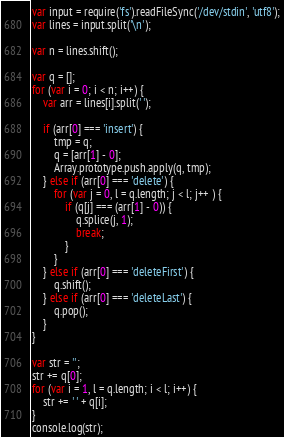Convert code to text. <code><loc_0><loc_0><loc_500><loc_500><_JavaScript_>var input = require('fs').readFileSync('/dev/stdin', 'utf8');
var lines = input.split('\n');

var n = lines.shift();

var q = [];
for (var i = 0; i < n; i++) {
	var arr = lines[i].split(' ');

	if (arr[0] === 'insert') {
		tmp = q;
		q = [arr[1] - 0];
		Array.prototype.push.apply(q, tmp);
	} else if (arr[0] === 'delete') {
		for (var j = 0, l = q.length; j < l; j++ ) {
			if (q[j] === (arr[1] - 0)) {
				q.splice(j, 1);
				break;
			}
		}
	} else if (arr[0] === 'deleteFirst') {
		q.shift();
	} else if (arr[0] === 'deleteLast') {
		q.pop();
	}
}

var str = '';
str += q[0];
for (var i = 1, l = q.length; i < l; i++) {
	str += ' ' + q[i];
}
console.log(str);</code> 